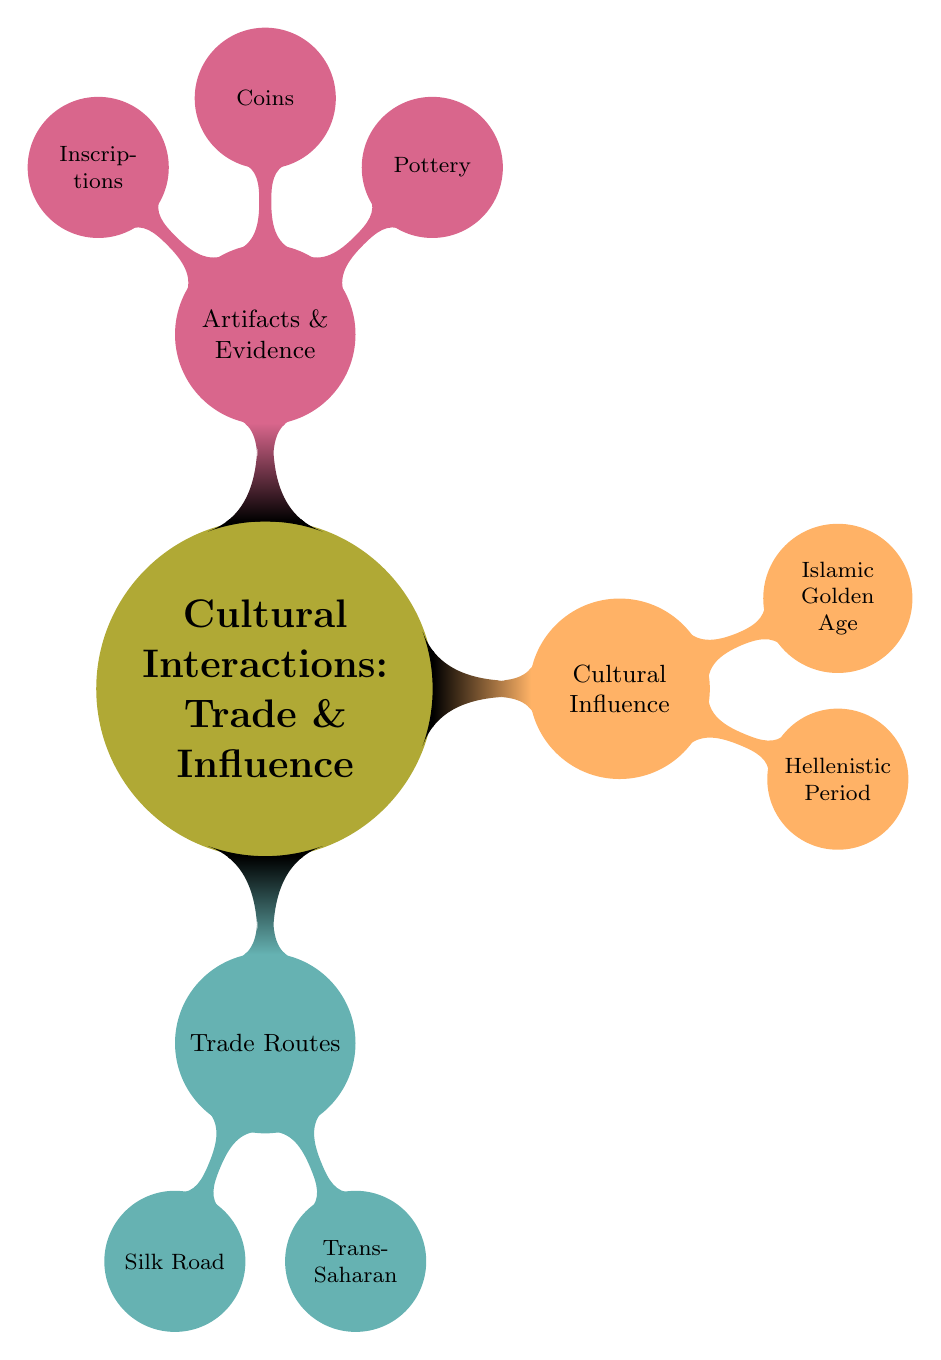What are the two main categories in the mind map? The mind map features three main categories: Trade Routes, Cultural Influence, and Artifacts & Evidence, but the question specifically asks for two main ones, which can be assumed to mean the most prominent themes presented: Trade Routes and Cultural Influence.
Answer: Trade Routes, Cultural Influence What are two goods exchanged on the Silk Road? The Silk Road is a trade route listed under the Trade Routes category. Within that section, the goods exchanged are explicitly stated as Silk, Spices, and Precious Stones. Therefore, two of these can be selected: Silk and Spices.
Answer: Silk, Spices How many regions are connected by the Trans-Saharan Trade? The Trans-Saharan Trade connects two regions specifically mentioned under its node: West Africa and North Africa. Counting these gives a total of two regions.
Answer: 2 What influence did the Hellenistic Period have on the regions listed? The Hellenistic Period, shown under the Cultural Influence category, explicitly lists the regions affected as Greece, Egypt, and Persia. Therefore, it had an influence on these three regions.
Answer: Greece, Egypt, Persia Which artifact type is associated with the Roman Denarii? In the Artifacts and Evidence section, Coins is a subcategory that explicitly lists Roman Denarii. Therefore, the associated artifact type is Coins.
Answer: Coins 